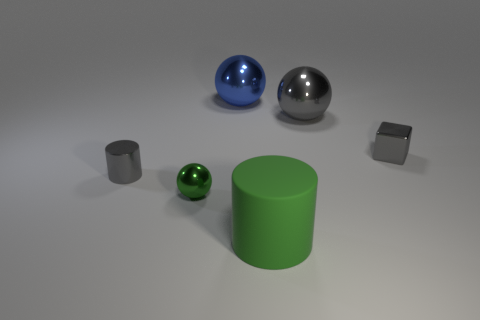Are there any other things that have the same material as the big green cylinder?
Your answer should be very brief. No. Is there a metallic block that has the same color as the tiny cylinder?
Your answer should be very brief. Yes. There is a ball that is the same color as the large rubber cylinder; what material is it?
Keep it short and to the point. Metal. What number of shiny balls are the same color as the large rubber cylinder?
Make the answer very short. 1. Do the green object behind the large cylinder and the gray metal thing to the left of the big blue metal ball have the same shape?
Provide a succinct answer. No. How many other objects are the same size as the matte object?
Provide a short and direct response. 2. The green metal sphere has what size?
Provide a succinct answer. Small. Does the small gray cylinder behind the large matte object have the same material as the tiny gray cube?
Make the answer very short. Yes. What color is the other large shiny thing that is the same shape as the big blue object?
Offer a very short reply. Gray. There is a small thing right of the tiny green object; is its color the same as the big cylinder?
Provide a succinct answer. No. 